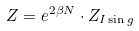Convert formula to latex. <formula><loc_0><loc_0><loc_500><loc_500>Z = e ^ { 2 \beta N } \cdot Z _ { I \sin g }</formula> 